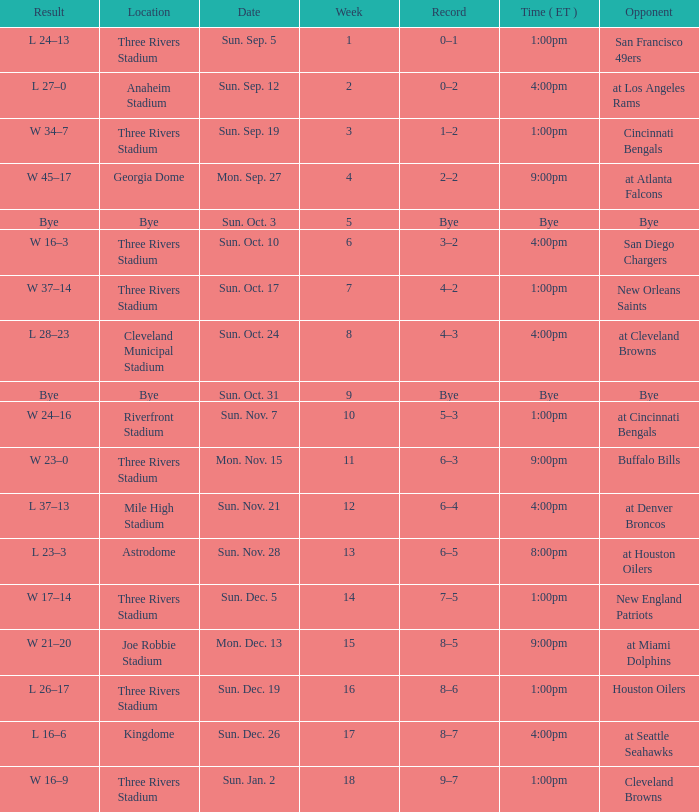What is the earliest week that shows a record of 8–5? 15.0. 